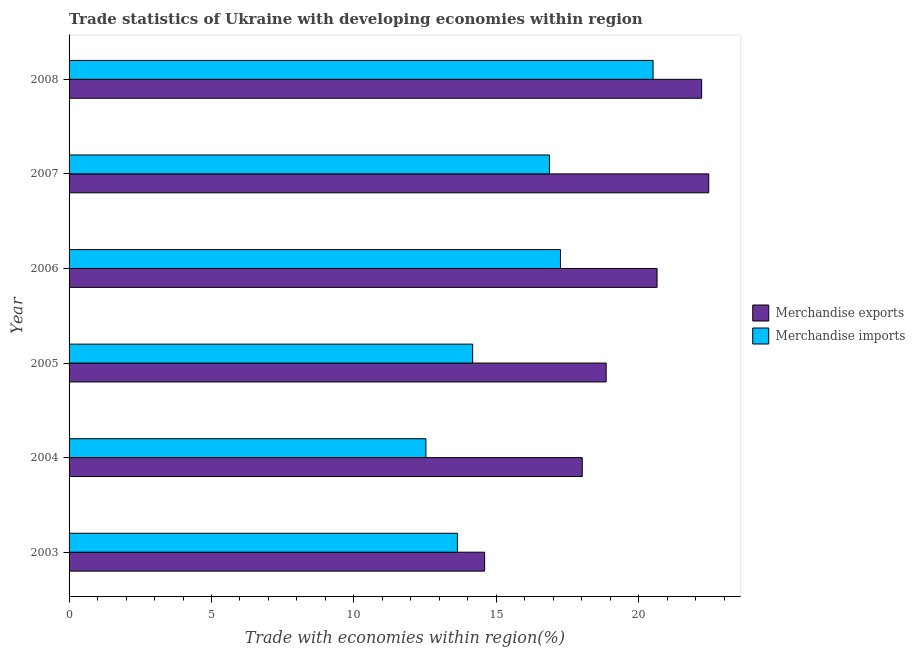How many different coloured bars are there?
Give a very brief answer. 2. How many groups of bars are there?
Your answer should be compact. 6. How many bars are there on the 6th tick from the top?
Offer a very short reply. 2. What is the label of the 3rd group of bars from the top?
Provide a succinct answer. 2006. In how many cases, is the number of bars for a given year not equal to the number of legend labels?
Provide a short and direct response. 0. What is the merchandise exports in 2008?
Ensure brevity in your answer.  22.21. Across all years, what is the maximum merchandise imports?
Ensure brevity in your answer.  20.5. Across all years, what is the minimum merchandise imports?
Keep it short and to the point. 12.53. What is the total merchandise exports in the graph?
Ensure brevity in your answer.  116.76. What is the difference between the merchandise imports in 2006 and that in 2007?
Provide a short and direct response. 0.39. What is the difference between the merchandise imports in 2006 and the merchandise exports in 2007?
Ensure brevity in your answer.  -5.21. What is the average merchandise imports per year?
Offer a very short reply. 15.82. In the year 2006, what is the difference between the merchandise exports and merchandise imports?
Ensure brevity in your answer.  3.39. In how many years, is the merchandise imports greater than 12 %?
Offer a very short reply. 6. What is the ratio of the merchandise exports in 2003 to that in 2006?
Keep it short and to the point. 0.71. Is the merchandise imports in 2003 less than that in 2006?
Offer a terse response. Yes. What is the difference between the highest and the second highest merchandise imports?
Give a very brief answer. 3.25. What is the difference between the highest and the lowest merchandise imports?
Provide a short and direct response. 7.97. In how many years, is the merchandise imports greater than the average merchandise imports taken over all years?
Your answer should be very brief. 3. Is the sum of the merchandise imports in 2003 and 2005 greater than the maximum merchandise exports across all years?
Your answer should be compact. Yes. What does the 1st bar from the top in 2006 represents?
Keep it short and to the point. Merchandise imports. What does the 1st bar from the bottom in 2007 represents?
Your answer should be compact. Merchandise exports. How many bars are there?
Provide a succinct answer. 12. What is the difference between two consecutive major ticks on the X-axis?
Offer a very short reply. 5. Are the values on the major ticks of X-axis written in scientific E-notation?
Your response must be concise. No. Does the graph contain any zero values?
Your answer should be compact. No. What is the title of the graph?
Make the answer very short. Trade statistics of Ukraine with developing economies within region. Does "Urban" appear as one of the legend labels in the graph?
Make the answer very short. No. What is the label or title of the X-axis?
Make the answer very short. Trade with economies within region(%). What is the label or title of the Y-axis?
Make the answer very short. Year. What is the Trade with economies within region(%) of Merchandise exports in 2003?
Offer a very short reply. 14.59. What is the Trade with economies within region(%) in Merchandise imports in 2003?
Give a very brief answer. 13.63. What is the Trade with economies within region(%) in Merchandise exports in 2004?
Your answer should be very brief. 18.02. What is the Trade with economies within region(%) of Merchandise imports in 2004?
Provide a succinct answer. 12.53. What is the Trade with economies within region(%) of Merchandise exports in 2005?
Offer a terse response. 18.85. What is the Trade with economies within region(%) of Merchandise imports in 2005?
Provide a succinct answer. 14.17. What is the Trade with economies within region(%) of Merchandise exports in 2006?
Provide a short and direct response. 20.64. What is the Trade with economies within region(%) in Merchandise imports in 2006?
Give a very brief answer. 17.25. What is the Trade with economies within region(%) in Merchandise exports in 2007?
Ensure brevity in your answer.  22.46. What is the Trade with economies within region(%) of Merchandise imports in 2007?
Provide a short and direct response. 16.86. What is the Trade with economies within region(%) in Merchandise exports in 2008?
Provide a short and direct response. 22.21. What is the Trade with economies within region(%) in Merchandise imports in 2008?
Offer a very short reply. 20.5. Across all years, what is the maximum Trade with economies within region(%) in Merchandise exports?
Make the answer very short. 22.46. Across all years, what is the maximum Trade with economies within region(%) of Merchandise imports?
Make the answer very short. 20.5. Across all years, what is the minimum Trade with economies within region(%) of Merchandise exports?
Offer a very short reply. 14.59. Across all years, what is the minimum Trade with economies within region(%) in Merchandise imports?
Offer a very short reply. 12.53. What is the total Trade with economies within region(%) in Merchandise exports in the graph?
Make the answer very short. 116.76. What is the total Trade with economies within region(%) in Merchandise imports in the graph?
Make the answer very short. 94.94. What is the difference between the Trade with economies within region(%) in Merchandise exports in 2003 and that in 2004?
Provide a succinct answer. -3.43. What is the difference between the Trade with economies within region(%) of Merchandise imports in 2003 and that in 2004?
Your answer should be very brief. 1.11. What is the difference between the Trade with economies within region(%) in Merchandise exports in 2003 and that in 2005?
Provide a short and direct response. -4.27. What is the difference between the Trade with economies within region(%) in Merchandise imports in 2003 and that in 2005?
Your answer should be very brief. -0.53. What is the difference between the Trade with economies within region(%) in Merchandise exports in 2003 and that in 2006?
Your answer should be very brief. -6.05. What is the difference between the Trade with economies within region(%) in Merchandise imports in 2003 and that in 2006?
Ensure brevity in your answer.  -3.62. What is the difference between the Trade with economies within region(%) of Merchandise exports in 2003 and that in 2007?
Ensure brevity in your answer.  -7.87. What is the difference between the Trade with economies within region(%) in Merchandise imports in 2003 and that in 2007?
Keep it short and to the point. -3.23. What is the difference between the Trade with economies within region(%) in Merchandise exports in 2003 and that in 2008?
Make the answer very short. -7.62. What is the difference between the Trade with economies within region(%) of Merchandise imports in 2003 and that in 2008?
Your answer should be compact. -6.87. What is the difference between the Trade with economies within region(%) of Merchandise exports in 2004 and that in 2005?
Keep it short and to the point. -0.84. What is the difference between the Trade with economies within region(%) of Merchandise imports in 2004 and that in 2005?
Your answer should be compact. -1.64. What is the difference between the Trade with economies within region(%) of Merchandise exports in 2004 and that in 2006?
Your answer should be very brief. -2.62. What is the difference between the Trade with economies within region(%) in Merchandise imports in 2004 and that in 2006?
Keep it short and to the point. -4.72. What is the difference between the Trade with economies within region(%) in Merchandise exports in 2004 and that in 2007?
Ensure brevity in your answer.  -4.44. What is the difference between the Trade with economies within region(%) in Merchandise imports in 2004 and that in 2007?
Your answer should be very brief. -4.34. What is the difference between the Trade with economies within region(%) of Merchandise exports in 2004 and that in 2008?
Ensure brevity in your answer.  -4.19. What is the difference between the Trade with economies within region(%) of Merchandise imports in 2004 and that in 2008?
Provide a short and direct response. -7.97. What is the difference between the Trade with economies within region(%) in Merchandise exports in 2005 and that in 2006?
Offer a very short reply. -1.79. What is the difference between the Trade with economies within region(%) in Merchandise imports in 2005 and that in 2006?
Your answer should be very brief. -3.08. What is the difference between the Trade with economies within region(%) in Merchandise exports in 2005 and that in 2007?
Ensure brevity in your answer.  -3.6. What is the difference between the Trade with economies within region(%) of Merchandise imports in 2005 and that in 2007?
Offer a terse response. -2.7. What is the difference between the Trade with economies within region(%) of Merchandise exports in 2005 and that in 2008?
Your answer should be compact. -3.35. What is the difference between the Trade with economies within region(%) in Merchandise imports in 2005 and that in 2008?
Offer a terse response. -6.33. What is the difference between the Trade with economies within region(%) of Merchandise exports in 2006 and that in 2007?
Your answer should be compact. -1.81. What is the difference between the Trade with economies within region(%) of Merchandise imports in 2006 and that in 2007?
Offer a terse response. 0.39. What is the difference between the Trade with economies within region(%) in Merchandise exports in 2006 and that in 2008?
Your answer should be very brief. -1.57. What is the difference between the Trade with economies within region(%) in Merchandise imports in 2006 and that in 2008?
Provide a succinct answer. -3.25. What is the difference between the Trade with economies within region(%) in Merchandise exports in 2007 and that in 2008?
Offer a very short reply. 0.25. What is the difference between the Trade with economies within region(%) in Merchandise imports in 2007 and that in 2008?
Offer a terse response. -3.64. What is the difference between the Trade with economies within region(%) of Merchandise exports in 2003 and the Trade with economies within region(%) of Merchandise imports in 2004?
Your answer should be compact. 2.06. What is the difference between the Trade with economies within region(%) in Merchandise exports in 2003 and the Trade with economies within region(%) in Merchandise imports in 2005?
Provide a succinct answer. 0.42. What is the difference between the Trade with economies within region(%) of Merchandise exports in 2003 and the Trade with economies within region(%) of Merchandise imports in 2006?
Your answer should be very brief. -2.66. What is the difference between the Trade with economies within region(%) in Merchandise exports in 2003 and the Trade with economies within region(%) in Merchandise imports in 2007?
Offer a terse response. -2.28. What is the difference between the Trade with economies within region(%) of Merchandise exports in 2003 and the Trade with economies within region(%) of Merchandise imports in 2008?
Your answer should be very brief. -5.91. What is the difference between the Trade with economies within region(%) of Merchandise exports in 2004 and the Trade with economies within region(%) of Merchandise imports in 2005?
Make the answer very short. 3.85. What is the difference between the Trade with economies within region(%) of Merchandise exports in 2004 and the Trade with economies within region(%) of Merchandise imports in 2006?
Your response must be concise. 0.77. What is the difference between the Trade with economies within region(%) of Merchandise exports in 2004 and the Trade with economies within region(%) of Merchandise imports in 2007?
Provide a short and direct response. 1.15. What is the difference between the Trade with economies within region(%) of Merchandise exports in 2004 and the Trade with economies within region(%) of Merchandise imports in 2008?
Keep it short and to the point. -2.49. What is the difference between the Trade with economies within region(%) in Merchandise exports in 2005 and the Trade with economies within region(%) in Merchandise imports in 2006?
Keep it short and to the point. 1.6. What is the difference between the Trade with economies within region(%) in Merchandise exports in 2005 and the Trade with economies within region(%) in Merchandise imports in 2007?
Make the answer very short. 1.99. What is the difference between the Trade with economies within region(%) of Merchandise exports in 2005 and the Trade with economies within region(%) of Merchandise imports in 2008?
Make the answer very short. -1.65. What is the difference between the Trade with economies within region(%) in Merchandise exports in 2006 and the Trade with economies within region(%) in Merchandise imports in 2007?
Offer a terse response. 3.78. What is the difference between the Trade with economies within region(%) of Merchandise exports in 2006 and the Trade with economies within region(%) of Merchandise imports in 2008?
Your answer should be very brief. 0.14. What is the difference between the Trade with economies within region(%) of Merchandise exports in 2007 and the Trade with economies within region(%) of Merchandise imports in 2008?
Make the answer very short. 1.95. What is the average Trade with economies within region(%) of Merchandise exports per year?
Give a very brief answer. 19.46. What is the average Trade with economies within region(%) of Merchandise imports per year?
Keep it short and to the point. 15.82. In the year 2003, what is the difference between the Trade with economies within region(%) of Merchandise exports and Trade with economies within region(%) of Merchandise imports?
Offer a very short reply. 0.96. In the year 2004, what is the difference between the Trade with economies within region(%) of Merchandise exports and Trade with economies within region(%) of Merchandise imports?
Keep it short and to the point. 5.49. In the year 2005, what is the difference between the Trade with economies within region(%) of Merchandise exports and Trade with economies within region(%) of Merchandise imports?
Your answer should be very brief. 4.69. In the year 2006, what is the difference between the Trade with economies within region(%) in Merchandise exports and Trade with economies within region(%) in Merchandise imports?
Keep it short and to the point. 3.39. In the year 2007, what is the difference between the Trade with economies within region(%) in Merchandise exports and Trade with economies within region(%) in Merchandise imports?
Offer a terse response. 5.59. In the year 2008, what is the difference between the Trade with economies within region(%) of Merchandise exports and Trade with economies within region(%) of Merchandise imports?
Offer a terse response. 1.71. What is the ratio of the Trade with economies within region(%) of Merchandise exports in 2003 to that in 2004?
Make the answer very short. 0.81. What is the ratio of the Trade with economies within region(%) of Merchandise imports in 2003 to that in 2004?
Give a very brief answer. 1.09. What is the ratio of the Trade with economies within region(%) of Merchandise exports in 2003 to that in 2005?
Offer a terse response. 0.77. What is the ratio of the Trade with economies within region(%) of Merchandise imports in 2003 to that in 2005?
Your answer should be very brief. 0.96. What is the ratio of the Trade with economies within region(%) of Merchandise exports in 2003 to that in 2006?
Offer a terse response. 0.71. What is the ratio of the Trade with economies within region(%) of Merchandise imports in 2003 to that in 2006?
Make the answer very short. 0.79. What is the ratio of the Trade with economies within region(%) in Merchandise exports in 2003 to that in 2007?
Give a very brief answer. 0.65. What is the ratio of the Trade with economies within region(%) in Merchandise imports in 2003 to that in 2007?
Provide a succinct answer. 0.81. What is the ratio of the Trade with economies within region(%) in Merchandise exports in 2003 to that in 2008?
Your answer should be compact. 0.66. What is the ratio of the Trade with economies within region(%) of Merchandise imports in 2003 to that in 2008?
Give a very brief answer. 0.67. What is the ratio of the Trade with economies within region(%) in Merchandise exports in 2004 to that in 2005?
Your answer should be compact. 0.96. What is the ratio of the Trade with economies within region(%) of Merchandise imports in 2004 to that in 2005?
Offer a very short reply. 0.88. What is the ratio of the Trade with economies within region(%) in Merchandise exports in 2004 to that in 2006?
Make the answer very short. 0.87. What is the ratio of the Trade with economies within region(%) in Merchandise imports in 2004 to that in 2006?
Your answer should be very brief. 0.73. What is the ratio of the Trade with economies within region(%) in Merchandise exports in 2004 to that in 2007?
Ensure brevity in your answer.  0.8. What is the ratio of the Trade with economies within region(%) of Merchandise imports in 2004 to that in 2007?
Offer a very short reply. 0.74. What is the ratio of the Trade with economies within region(%) in Merchandise exports in 2004 to that in 2008?
Provide a short and direct response. 0.81. What is the ratio of the Trade with economies within region(%) of Merchandise imports in 2004 to that in 2008?
Offer a very short reply. 0.61. What is the ratio of the Trade with economies within region(%) in Merchandise exports in 2005 to that in 2006?
Your answer should be very brief. 0.91. What is the ratio of the Trade with economies within region(%) in Merchandise imports in 2005 to that in 2006?
Your answer should be very brief. 0.82. What is the ratio of the Trade with economies within region(%) of Merchandise exports in 2005 to that in 2007?
Offer a terse response. 0.84. What is the ratio of the Trade with economies within region(%) of Merchandise imports in 2005 to that in 2007?
Your response must be concise. 0.84. What is the ratio of the Trade with economies within region(%) of Merchandise exports in 2005 to that in 2008?
Give a very brief answer. 0.85. What is the ratio of the Trade with economies within region(%) in Merchandise imports in 2005 to that in 2008?
Keep it short and to the point. 0.69. What is the ratio of the Trade with economies within region(%) in Merchandise exports in 2006 to that in 2007?
Your answer should be compact. 0.92. What is the ratio of the Trade with economies within region(%) of Merchandise imports in 2006 to that in 2007?
Provide a short and direct response. 1.02. What is the ratio of the Trade with economies within region(%) of Merchandise exports in 2006 to that in 2008?
Your answer should be compact. 0.93. What is the ratio of the Trade with economies within region(%) in Merchandise imports in 2006 to that in 2008?
Your response must be concise. 0.84. What is the ratio of the Trade with economies within region(%) in Merchandise exports in 2007 to that in 2008?
Offer a terse response. 1.01. What is the ratio of the Trade with economies within region(%) in Merchandise imports in 2007 to that in 2008?
Your response must be concise. 0.82. What is the difference between the highest and the second highest Trade with economies within region(%) of Merchandise exports?
Ensure brevity in your answer.  0.25. What is the difference between the highest and the second highest Trade with economies within region(%) of Merchandise imports?
Offer a terse response. 3.25. What is the difference between the highest and the lowest Trade with economies within region(%) of Merchandise exports?
Your answer should be compact. 7.87. What is the difference between the highest and the lowest Trade with economies within region(%) of Merchandise imports?
Give a very brief answer. 7.97. 